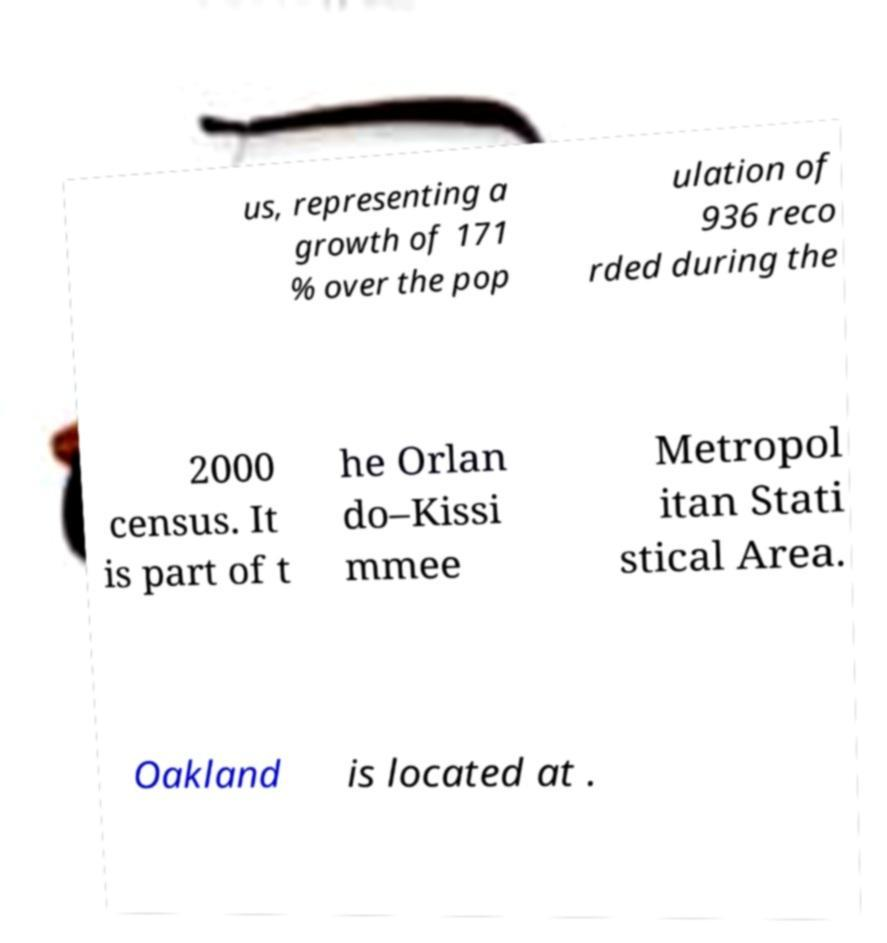Please identify and transcribe the text found in this image. us, representing a growth of 171 % over the pop ulation of 936 reco rded during the 2000 census. It is part of t he Orlan do–Kissi mmee Metropol itan Stati stical Area. Oakland is located at . 